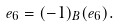<formula> <loc_0><loc_0><loc_500><loc_500>e _ { 6 } = ( - 1 ) _ { B } ( e _ { 6 } ) .</formula> 